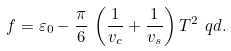<formula> <loc_0><loc_0><loc_500><loc_500>f = \varepsilon _ { 0 } - \frac { \pi } { 6 } \, \left ( \frac { 1 } { v _ { c } } + \frac { 1 } { v _ { s } } \right ) T ^ { 2 } \ q d .</formula> 